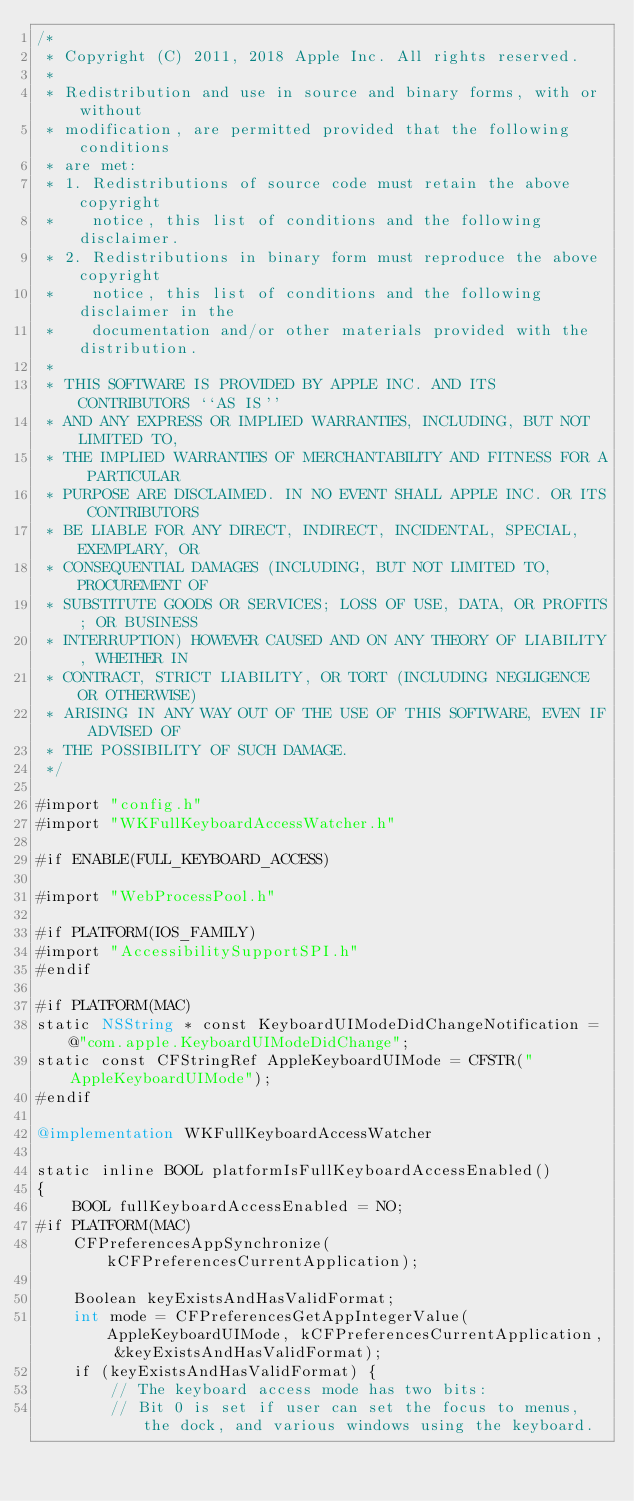Convert code to text. <code><loc_0><loc_0><loc_500><loc_500><_ObjectiveC_>/*
 * Copyright (C) 2011, 2018 Apple Inc. All rights reserved.
 *
 * Redistribution and use in source and binary forms, with or without
 * modification, are permitted provided that the following conditions
 * are met:
 * 1. Redistributions of source code must retain the above copyright
 *    notice, this list of conditions and the following disclaimer.
 * 2. Redistributions in binary form must reproduce the above copyright
 *    notice, this list of conditions and the following disclaimer in the
 *    documentation and/or other materials provided with the distribution.
 *
 * THIS SOFTWARE IS PROVIDED BY APPLE INC. AND ITS CONTRIBUTORS ``AS IS''
 * AND ANY EXPRESS OR IMPLIED WARRANTIES, INCLUDING, BUT NOT LIMITED TO,
 * THE IMPLIED WARRANTIES OF MERCHANTABILITY AND FITNESS FOR A PARTICULAR
 * PURPOSE ARE DISCLAIMED. IN NO EVENT SHALL APPLE INC. OR ITS CONTRIBUTORS
 * BE LIABLE FOR ANY DIRECT, INDIRECT, INCIDENTAL, SPECIAL, EXEMPLARY, OR
 * CONSEQUENTIAL DAMAGES (INCLUDING, BUT NOT LIMITED TO, PROCUREMENT OF
 * SUBSTITUTE GOODS OR SERVICES; LOSS OF USE, DATA, OR PROFITS; OR BUSINESS
 * INTERRUPTION) HOWEVER CAUSED AND ON ANY THEORY OF LIABILITY, WHETHER IN
 * CONTRACT, STRICT LIABILITY, OR TORT (INCLUDING NEGLIGENCE OR OTHERWISE)
 * ARISING IN ANY WAY OUT OF THE USE OF THIS SOFTWARE, EVEN IF ADVISED OF
 * THE POSSIBILITY OF SUCH DAMAGE.
 */

#import "config.h"
#import "WKFullKeyboardAccessWatcher.h"

#if ENABLE(FULL_KEYBOARD_ACCESS)

#import "WebProcessPool.h"

#if PLATFORM(IOS_FAMILY)
#import "AccessibilitySupportSPI.h"
#endif

#if PLATFORM(MAC)
static NSString * const KeyboardUIModeDidChangeNotification = @"com.apple.KeyboardUIModeDidChange";
static const CFStringRef AppleKeyboardUIMode = CFSTR("AppleKeyboardUIMode");
#endif

@implementation WKFullKeyboardAccessWatcher

static inline BOOL platformIsFullKeyboardAccessEnabled()
{
    BOOL fullKeyboardAccessEnabled = NO;
#if PLATFORM(MAC)
    CFPreferencesAppSynchronize(kCFPreferencesCurrentApplication);
    
    Boolean keyExistsAndHasValidFormat;
    int mode = CFPreferencesGetAppIntegerValue(AppleKeyboardUIMode, kCFPreferencesCurrentApplication, &keyExistsAndHasValidFormat);
    if (keyExistsAndHasValidFormat) {
        // The keyboard access mode has two bits:
        // Bit 0 is set if user can set the focus to menus, the dock, and various windows using the keyboard.</code> 